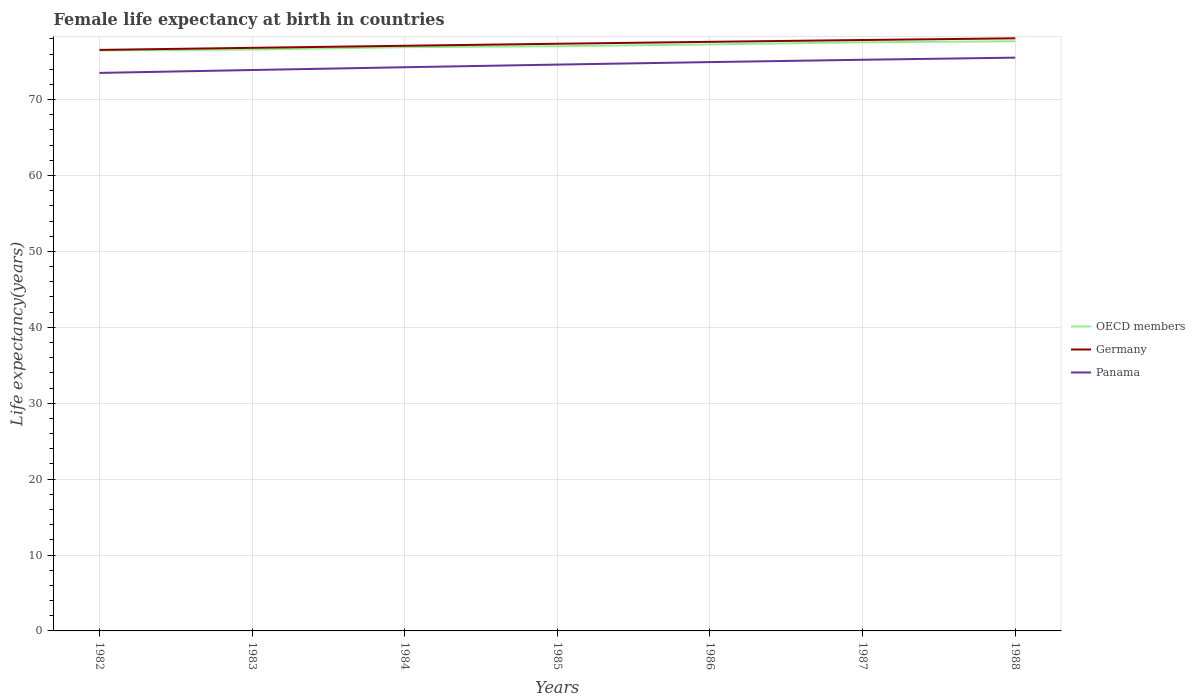How many different coloured lines are there?
Your answer should be very brief. 3. Is the number of lines equal to the number of legend labels?
Offer a very short reply. Yes. Across all years, what is the maximum female life expectancy at birth in Panama?
Make the answer very short. 73.52. In which year was the female life expectancy at birth in OECD members maximum?
Your answer should be very brief. 1982. What is the total female life expectancy at birth in Germany in the graph?
Your response must be concise. -0.54. What is the difference between the highest and the second highest female life expectancy at birth in Germany?
Offer a terse response. 1.53. What is the difference between the highest and the lowest female life expectancy at birth in OECD members?
Make the answer very short. 3. How many years are there in the graph?
Your answer should be compact. 7. Does the graph contain any zero values?
Your response must be concise. No. Does the graph contain grids?
Offer a very short reply. Yes. What is the title of the graph?
Offer a very short reply. Female life expectancy at birth in countries. Does "Bosnia and Herzegovina" appear as one of the legend labels in the graph?
Your answer should be very brief. No. What is the label or title of the X-axis?
Keep it short and to the point. Years. What is the label or title of the Y-axis?
Your answer should be very brief. Life expectancy(years). What is the Life expectancy(years) in OECD members in 1982?
Keep it short and to the point. 76.48. What is the Life expectancy(years) of Germany in 1982?
Make the answer very short. 76.55. What is the Life expectancy(years) of Panama in 1982?
Make the answer very short. 73.52. What is the Life expectancy(years) of OECD members in 1983?
Provide a short and direct response. 76.6. What is the Life expectancy(years) of Germany in 1983?
Offer a very short reply. 76.82. What is the Life expectancy(years) in Panama in 1983?
Offer a terse response. 73.9. What is the Life expectancy(years) in OECD members in 1984?
Your answer should be very brief. 76.9. What is the Life expectancy(years) of Germany in 1984?
Give a very brief answer. 77.1. What is the Life expectancy(years) of Panama in 1984?
Keep it short and to the point. 74.27. What is the Life expectancy(years) in OECD members in 1985?
Keep it short and to the point. 77.03. What is the Life expectancy(years) of Germany in 1985?
Offer a very short reply. 77.36. What is the Life expectancy(years) of Panama in 1985?
Your response must be concise. 74.61. What is the Life expectancy(years) of OECD members in 1986?
Give a very brief answer. 77.27. What is the Life expectancy(years) in Germany in 1986?
Give a very brief answer. 77.61. What is the Life expectancy(years) of Panama in 1986?
Make the answer very short. 74.94. What is the Life expectancy(years) in OECD members in 1987?
Keep it short and to the point. 77.56. What is the Life expectancy(years) of Germany in 1987?
Offer a very short reply. 77.85. What is the Life expectancy(years) of Panama in 1987?
Provide a short and direct response. 75.25. What is the Life expectancy(years) in OECD members in 1988?
Your response must be concise. 77.69. What is the Life expectancy(years) in Germany in 1988?
Your answer should be very brief. 78.08. What is the Life expectancy(years) of Panama in 1988?
Your answer should be compact. 75.53. Across all years, what is the maximum Life expectancy(years) in OECD members?
Provide a short and direct response. 77.69. Across all years, what is the maximum Life expectancy(years) of Germany?
Make the answer very short. 78.08. Across all years, what is the maximum Life expectancy(years) in Panama?
Ensure brevity in your answer.  75.53. Across all years, what is the minimum Life expectancy(years) in OECD members?
Your response must be concise. 76.48. Across all years, what is the minimum Life expectancy(years) of Germany?
Offer a terse response. 76.55. Across all years, what is the minimum Life expectancy(years) of Panama?
Make the answer very short. 73.52. What is the total Life expectancy(years) in OECD members in the graph?
Give a very brief answer. 539.53. What is the total Life expectancy(years) in Germany in the graph?
Provide a succinct answer. 541.37. What is the total Life expectancy(years) of Panama in the graph?
Keep it short and to the point. 522.03. What is the difference between the Life expectancy(years) in OECD members in 1982 and that in 1983?
Provide a short and direct response. -0.12. What is the difference between the Life expectancy(years) in Germany in 1982 and that in 1983?
Offer a very short reply. -0.27. What is the difference between the Life expectancy(years) of Panama in 1982 and that in 1983?
Provide a succinct answer. -0.38. What is the difference between the Life expectancy(years) in OECD members in 1982 and that in 1984?
Provide a short and direct response. -0.43. What is the difference between the Life expectancy(years) of Germany in 1982 and that in 1984?
Give a very brief answer. -0.55. What is the difference between the Life expectancy(years) of Panama in 1982 and that in 1984?
Your answer should be very brief. -0.75. What is the difference between the Life expectancy(years) in OECD members in 1982 and that in 1985?
Provide a succinct answer. -0.56. What is the difference between the Life expectancy(years) of Germany in 1982 and that in 1985?
Your response must be concise. -0.81. What is the difference between the Life expectancy(years) in Panama in 1982 and that in 1985?
Provide a short and direct response. -1.09. What is the difference between the Life expectancy(years) in OECD members in 1982 and that in 1986?
Your answer should be very brief. -0.79. What is the difference between the Life expectancy(years) of Germany in 1982 and that in 1986?
Your answer should be compact. -1.06. What is the difference between the Life expectancy(years) of Panama in 1982 and that in 1986?
Ensure brevity in your answer.  -1.42. What is the difference between the Life expectancy(years) of OECD members in 1982 and that in 1987?
Make the answer very short. -1.08. What is the difference between the Life expectancy(years) of Germany in 1982 and that in 1987?
Offer a very short reply. -1.3. What is the difference between the Life expectancy(years) of Panama in 1982 and that in 1987?
Your answer should be very brief. -1.73. What is the difference between the Life expectancy(years) in OECD members in 1982 and that in 1988?
Make the answer very short. -1.21. What is the difference between the Life expectancy(years) in Germany in 1982 and that in 1988?
Your response must be concise. -1.53. What is the difference between the Life expectancy(years) of Panama in 1982 and that in 1988?
Your answer should be compact. -2.01. What is the difference between the Life expectancy(years) in OECD members in 1983 and that in 1984?
Your answer should be very brief. -0.31. What is the difference between the Life expectancy(years) in Germany in 1983 and that in 1984?
Provide a short and direct response. -0.27. What is the difference between the Life expectancy(years) in Panama in 1983 and that in 1984?
Ensure brevity in your answer.  -0.36. What is the difference between the Life expectancy(years) of OECD members in 1983 and that in 1985?
Offer a very short reply. -0.44. What is the difference between the Life expectancy(years) of Germany in 1983 and that in 1985?
Provide a succinct answer. -0.54. What is the difference between the Life expectancy(years) in Panama in 1983 and that in 1985?
Offer a terse response. -0.71. What is the difference between the Life expectancy(years) in OECD members in 1983 and that in 1986?
Provide a succinct answer. -0.67. What is the difference between the Life expectancy(years) of Germany in 1983 and that in 1986?
Your answer should be compact. -0.79. What is the difference between the Life expectancy(years) of Panama in 1983 and that in 1986?
Provide a short and direct response. -1.04. What is the difference between the Life expectancy(years) of OECD members in 1983 and that in 1987?
Make the answer very short. -0.96. What is the difference between the Life expectancy(years) of Germany in 1983 and that in 1987?
Offer a terse response. -1.03. What is the difference between the Life expectancy(years) in Panama in 1983 and that in 1987?
Make the answer very short. -1.35. What is the difference between the Life expectancy(years) in OECD members in 1983 and that in 1988?
Your answer should be very brief. -1.09. What is the difference between the Life expectancy(years) in Germany in 1983 and that in 1988?
Provide a short and direct response. -1.25. What is the difference between the Life expectancy(years) of Panama in 1983 and that in 1988?
Provide a short and direct response. -1.63. What is the difference between the Life expectancy(years) of OECD members in 1984 and that in 1985?
Provide a short and direct response. -0.13. What is the difference between the Life expectancy(years) in Germany in 1984 and that in 1985?
Offer a very short reply. -0.26. What is the difference between the Life expectancy(years) in Panama in 1984 and that in 1985?
Offer a terse response. -0.35. What is the difference between the Life expectancy(years) of OECD members in 1984 and that in 1986?
Provide a short and direct response. -0.37. What is the difference between the Life expectancy(years) in Germany in 1984 and that in 1986?
Give a very brief answer. -0.52. What is the difference between the Life expectancy(years) of Panama in 1984 and that in 1986?
Your answer should be very brief. -0.68. What is the difference between the Life expectancy(years) in OECD members in 1984 and that in 1987?
Make the answer very short. -0.65. What is the difference between the Life expectancy(years) in Germany in 1984 and that in 1987?
Keep it short and to the point. -0.76. What is the difference between the Life expectancy(years) in Panama in 1984 and that in 1987?
Keep it short and to the point. -0.98. What is the difference between the Life expectancy(years) in OECD members in 1984 and that in 1988?
Offer a terse response. -0.78. What is the difference between the Life expectancy(years) in Germany in 1984 and that in 1988?
Your answer should be very brief. -0.98. What is the difference between the Life expectancy(years) in Panama in 1984 and that in 1988?
Provide a short and direct response. -1.26. What is the difference between the Life expectancy(years) in OECD members in 1985 and that in 1986?
Your response must be concise. -0.24. What is the difference between the Life expectancy(years) of Germany in 1985 and that in 1986?
Give a very brief answer. -0.25. What is the difference between the Life expectancy(years) in Panama in 1985 and that in 1986?
Offer a terse response. -0.33. What is the difference between the Life expectancy(years) of OECD members in 1985 and that in 1987?
Offer a terse response. -0.52. What is the difference between the Life expectancy(years) in Germany in 1985 and that in 1987?
Provide a short and direct response. -0.49. What is the difference between the Life expectancy(years) of Panama in 1985 and that in 1987?
Provide a short and direct response. -0.64. What is the difference between the Life expectancy(years) in OECD members in 1985 and that in 1988?
Keep it short and to the point. -0.65. What is the difference between the Life expectancy(years) of Germany in 1985 and that in 1988?
Your answer should be very brief. -0.72. What is the difference between the Life expectancy(years) of Panama in 1985 and that in 1988?
Offer a very short reply. -0.92. What is the difference between the Life expectancy(years) of OECD members in 1986 and that in 1987?
Offer a terse response. -0.29. What is the difference between the Life expectancy(years) of Germany in 1986 and that in 1987?
Provide a short and direct response. -0.24. What is the difference between the Life expectancy(years) of Panama in 1986 and that in 1987?
Your answer should be very brief. -0.31. What is the difference between the Life expectancy(years) in OECD members in 1986 and that in 1988?
Offer a very short reply. -0.42. What is the difference between the Life expectancy(years) in Germany in 1986 and that in 1988?
Give a very brief answer. -0.47. What is the difference between the Life expectancy(years) of Panama in 1986 and that in 1988?
Your response must be concise. -0.59. What is the difference between the Life expectancy(years) in OECD members in 1987 and that in 1988?
Give a very brief answer. -0.13. What is the difference between the Life expectancy(years) of Germany in 1987 and that in 1988?
Offer a terse response. -0.23. What is the difference between the Life expectancy(years) in Panama in 1987 and that in 1988?
Give a very brief answer. -0.28. What is the difference between the Life expectancy(years) of OECD members in 1982 and the Life expectancy(years) of Germany in 1983?
Make the answer very short. -0.35. What is the difference between the Life expectancy(years) of OECD members in 1982 and the Life expectancy(years) of Panama in 1983?
Your answer should be very brief. 2.58. What is the difference between the Life expectancy(years) in Germany in 1982 and the Life expectancy(years) in Panama in 1983?
Make the answer very short. 2.65. What is the difference between the Life expectancy(years) in OECD members in 1982 and the Life expectancy(years) in Germany in 1984?
Provide a short and direct response. -0.62. What is the difference between the Life expectancy(years) of OECD members in 1982 and the Life expectancy(years) of Panama in 1984?
Provide a succinct answer. 2.21. What is the difference between the Life expectancy(years) of Germany in 1982 and the Life expectancy(years) of Panama in 1984?
Keep it short and to the point. 2.28. What is the difference between the Life expectancy(years) in OECD members in 1982 and the Life expectancy(years) in Germany in 1985?
Your answer should be very brief. -0.88. What is the difference between the Life expectancy(years) of OECD members in 1982 and the Life expectancy(years) of Panama in 1985?
Ensure brevity in your answer.  1.86. What is the difference between the Life expectancy(years) in Germany in 1982 and the Life expectancy(years) in Panama in 1985?
Keep it short and to the point. 1.94. What is the difference between the Life expectancy(years) in OECD members in 1982 and the Life expectancy(years) in Germany in 1986?
Ensure brevity in your answer.  -1.14. What is the difference between the Life expectancy(years) in OECD members in 1982 and the Life expectancy(years) in Panama in 1986?
Your response must be concise. 1.53. What is the difference between the Life expectancy(years) in Germany in 1982 and the Life expectancy(years) in Panama in 1986?
Provide a short and direct response. 1.61. What is the difference between the Life expectancy(years) in OECD members in 1982 and the Life expectancy(years) in Germany in 1987?
Your answer should be very brief. -1.37. What is the difference between the Life expectancy(years) in OECD members in 1982 and the Life expectancy(years) in Panama in 1987?
Your answer should be very brief. 1.23. What is the difference between the Life expectancy(years) of Germany in 1982 and the Life expectancy(years) of Panama in 1987?
Ensure brevity in your answer.  1.3. What is the difference between the Life expectancy(years) in OECD members in 1982 and the Life expectancy(years) in Germany in 1988?
Ensure brevity in your answer.  -1.6. What is the difference between the Life expectancy(years) of OECD members in 1982 and the Life expectancy(years) of Panama in 1988?
Keep it short and to the point. 0.95. What is the difference between the Life expectancy(years) in Germany in 1982 and the Life expectancy(years) in Panama in 1988?
Provide a short and direct response. 1.02. What is the difference between the Life expectancy(years) in OECD members in 1983 and the Life expectancy(years) in Germany in 1984?
Make the answer very short. -0.5. What is the difference between the Life expectancy(years) of OECD members in 1983 and the Life expectancy(years) of Panama in 1984?
Offer a terse response. 2.33. What is the difference between the Life expectancy(years) in Germany in 1983 and the Life expectancy(years) in Panama in 1984?
Give a very brief answer. 2.56. What is the difference between the Life expectancy(years) in OECD members in 1983 and the Life expectancy(years) in Germany in 1985?
Keep it short and to the point. -0.76. What is the difference between the Life expectancy(years) of OECD members in 1983 and the Life expectancy(years) of Panama in 1985?
Give a very brief answer. 1.98. What is the difference between the Life expectancy(years) in Germany in 1983 and the Life expectancy(years) in Panama in 1985?
Provide a succinct answer. 2.21. What is the difference between the Life expectancy(years) in OECD members in 1983 and the Life expectancy(years) in Germany in 1986?
Offer a terse response. -1.02. What is the difference between the Life expectancy(years) of OECD members in 1983 and the Life expectancy(years) of Panama in 1986?
Your answer should be compact. 1.65. What is the difference between the Life expectancy(years) of Germany in 1983 and the Life expectancy(years) of Panama in 1986?
Offer a very short reply. 1.88. What is the difference between the Life expectancy(years) in OECD members in 1983 and the Life expectancy(years) in Germany in 1987?
Your answer should be very brief. -1.25. What is the difference between the Life expectancy(years) in OECD members in 1983 and the Life expectancy(years) in Panama in 1987?
Provide a succinct answer. 1.35. What is the difference between the Life expectancy(years) in Germany in 1983 and the Life expectancy(years) in Panama in 1987?
Give a very brief answer. 1.57. What is the difference between the Life expectancy(years) of OECD members in 1983 and the Life expectancy(years) of Germany in 1988?
Make the answer very short. -1.48. What is the difference between the Life expectancy(years) of OECD members in 1983 and the Life expectancy(years) of Panama in 1988?
Keep it short and to the point. 1.07. What is the difference between the Life expectancy(years) of Germany in 1983 and the Life expectancy(years) of Panama in 1988?
Give a very brief answer. 1.29. What is the difference between the Life expectancy(years) in OECD members in 1984 and the Life expectancy(years) in Germany in 1985?
Keep it short and to the point. -0.46. What is the difference between the Life expectancy(years) of OECD members in 1984 and the Life expectancy(years) of Panama in 1985?
Offer a terse response. 2.29. What is the difference between the Life expectancy(years) in Germany in 1984 and the Life expectancy(years) in Panama in 1985?
Provide a succinct answer. 2.48. What is the difference between the Life expectancy(years) in OECD members in 1984 and the Life expectancy(years) in Germany in 1986?
Keep it short and to the point. -0.71. What is the difference between the Life expectancy(years) in OECD members in 1984 and the Life expectancy(years) in Panama in 1986?
Your answer should be compact. 1.96. What is the difference between the Life expectancy(years) in Germany in 1984 and the Life expectancy(years) in Panama in 1986?
Your answer should be very brief. 2.15. What is the difference between the Life expectancy(years) of OECD members in 1984 and the Life expectancy(years) of Germany in 1987?
Offer a very short reply. -0.95. What is the difference between the Life expectancy(years) in OECD members in 1984 and the Life expectancy(years) in Panama in 1987?
Give a very brief answer. 1.65. What is the difference between the Life expectancy(years) of Germany in 1984 and the Life expectancy(years) of Panama in 1987?
Ensure brevity in your answer.  1.85. What is the difference between the Life expectancy(years) in OECD members in 1984 and the Life expectancy(years) in Germany in 1988?
Give a very brief answer. -1.17. What is the difference between the Life expectancy(years) of OECD members in 1984 and the Life expectancy(years) of Panama in 1988?
Offer a very short reply. 1.37. What is the difference between the Life expectancy(years) of Germany in 1984 and the Life expectancy(years) of Panama in 1988?
Keep it short and to the point. 1.56. What is the difference between the Life expectancy(years) in OECD members in 1985 and the Life expectancy(years) in Germany in 1986?
Provide a succinct answer. -0.58. What is the difference between the Life expectancy(years) of OECD members in 1985 and the Life expectancy(years) of Panama in 1986?
Offer a very short reply. 2.09. What is the difference between the Life expectancy(years) of Germany in 1985 and the Life expectancy(years) of Panama in 1986?
Your answer should be compact. 2.42. What is the difference between the Life expectancy(years) of OECD members in 1985 and the Life expectancy(years) of Germany in 1987?
Your answer should be compact. -0.82. What is the difference between the Life expectancy(years) of OECD members in 1985 and the Life expectancy(years) of Panama in 1987?
Ensure brevity in your answer.  1.78. What is the difference between the Life expectancy(years) of Germany in 1985 and the Life expectancy(years) of Panama in 1987?
Offer a terse response. 2.11. What is the difference between the Life expectancy(years) in OECD members in 1985 and the Life expectancy(years) in Germany in 1988?
Provide a succinct answer. -1.04. What is the difference between the Life expectancy(years) in OECD members in 1985 and the Life expectancy(years) in Panama in 1988?
Offer a very short reply. 1.5. What is the difference between the Life expectancy(years) in Germany in 1985 and the Life expectancy(years) in Panama in 1988?
Your answer should be very brief. 1.83. What is the difference between the Life expectancy(years) of OECD members in 1986 and the Life expectancy(years) of Germany in 1987?
Your answer should be compact. -0.58. What is the difference between the Life expectancy(years) of OECD members in 1986 and the Life expectancy(years) of Panama in 1987?
Your answer should be compact. 2.02. What is the difference between the Life expectancy(years) of Germany in 1986 and the Life expectancy(years) of Panama in 1987?
Offer a very short reply. 2.36. What is the difference between the Life expectancy(years) of OECD members in 1986 and the Life expectancy(years) of Germany in 1988?
Offer a very short reply. -0.81. What is the difference between the Life expectancy(years) in OECD members in 1986 and the Life expectancy(years) in Panama in 1988?
Make the answer very short. 1.74. What is the difference between the Life expectancy(years) of Germany in 1986 and the Life expectancy(years) of Panama in 1988?
Ensure brevity in your answer.  2.08. What is the difference between the Life expectancy(years) of OECD members in 1987 and the Life expectancy(years) of Germany in 1988?
Provide a succinct answer. -0.52. What is the difference between the Life expectancy(years) of OECD members in 1987 and the Life expectancy(years) of Panama in 1988?
Your answer should be very brief. 2.02. What is the difference between the Life expectancy(years) of Germany in 1987 and the Life expectancy(years) of Panama in 1988?
Your answer should be compact. 2.32. What is the average Life expectancy(years) in OECD members per year?
Keep it short and to the point. 77.08. What is the average Life expectancy(years) in Germany per year?
Offer a terse response. 77.34. What is the average Life expectancy(years) of Panama per year?
Keep it short and to the point. 74.58. In the year 1982, what is the difference between the Life expectancy(years) in OECD members and Life expectancy(years) in Germany?
Ensure brevity in your answer.  -0.07. In the year 1982, what is the difference between the Life expectancy(years) in OECD members and Life expectancy(years) in Panama?
Your response must be concise. 2.96. In the year 1982, what is the difference between the Life expectancy(years) in Germany and Life expectancy(years) in Panama?
Your answer should be very brief. 3.03. In the year 1983, what is the difference between the Life expectancy(years) in OECD members and Life expectancy(years) in Germany?
Keep it short and to the point. -0.23. In the year 1983, what is the difference between the Life expectancy(years) in OECD members and Life expectancy(years) in Panama?
Provide a succinct answer. 2.7. In the year 1983, what is the difference between the Life expectancy(years) of Germany and Life expectancy(years) of Panama?
Offer a terse response. 2.92. In the year 1984, what is the difference between the Life expectancy(years) in OECD members and Life expectancy(years) in Germany?
Keep it short and to the point. -0.19. In the year 1984, what is the difference between the Life expectancy(years) of OECD members and Life expectancy(years) of Panama?
Your answer should be compact. 2.64. In the year 1984, what is the difference between the Life expectancy(years) of Germany and Life expectancy(years) of Panama?
Your answer should be very brief. 2.83. In the year 1985, what is the difference between the Life expectancy(years) in OECD members and Life expectancy(years) in Germany?
Your response must be concise. -0.33. In the year 1985, what is the difference between the Life expectancy(years) in OECD members and Life expectancy(years) in Panama?
Make the answer very short. 2.42. In the year 1985, what is the difference between the Life expectancy(years) in Germany and Life expectancy(years) in Panama?
Make the answer very short. 2.75. In the year 1986, what is the difference between the Life expectancy(years) in OECD members and Life expectancy(years) in Germany?
Keep it short and to the point. -0.34. In the year 1986, what is the difference between the Life expectancy(years) of OECD members and Life expectancy(years) of Panama?
Ensure brevity in your answer.  2.33. In the year 1986, what is the difference between the Life expectancy(years) of Germany and Life expectancy(years) of Panama?
Keep it short and to the point. 2.67. In the year 1987, what is the difference between the Life expectancy(years) in OECD members and Life expectancy(years) in Germany?
Offer a very short reply. -0.3. In the year 1987, what is the difference between the Life expectancy(years) in OECD members and Life expectancy(years) in Panama?
Give a very brief answer. 2.31. In the year 1987, what is the difference between the Life expectancy(years) in Germany and Life expectancy(years) in Panama?
Your answer should be compact. 2.6. In the year 1988, what is the difference between the Life expectancy(years) of OECD members and Life expectancy(years) of Germany?
Provide a succinct answer. -0.39. In the year 1988, what is the difference between the Life expectancy(years) of OECD members and Life expectancy(years) of Panama?
Your answer should be compact. 2.16. In the year 1988, what is the difference between the Life expectancy(years) in Germany and Life expectancy(years) in Panama?
Your answer should be very brief. 2.55. What is the ratio of the Life expectancy(years) in Panama in 1982 to that in 1983?
Your answer should be very brief. 0.99. What is the ratio of the Life expectancy(years) of Germany in 1982 to that in 1984?
Ensure brevity in your answer.  0.99. What is the ratio of the Life expectancy(years) of Germany in 1982 to that in 1986?
Give a very brief answer. 0.99. What is the ratio of the Life expectancy(years) in OECD members in 1982 to that in 1987?
Provide a short and direct response. 0.99. What is the ratio of the Life expectancy(years) of Germany in 1982 to that in 1987?
Provide a short and direct response. 0.98. What is the ratio of the Life expectancy(years) in OECD members in 1982 to that in 1988?
Give a very brief answer. 0.98. What is the ratio of the Life expectancy(years) of Germany in 1982 to that in 1988?
Ensure brevity in your answer.  0.98. What is the ratio of the Life expectancy(years) in Panama in 1982 to that in 1988?
Your answer should be very brief. 0.97. What is the ratio of the Life expectancy(years) in Panama in 1983 to that in 1984?
Your answer should be compact. 1. What is the ratio of the Life expectancy(years) of Panama in 1983 to that in 1986?
Give a very brief answer. 0.99. What is the ratio of the Life expectancy(years) in OECD members in 1983 to that in 1987?
Keep it short and to the point. 0.99. What is the ratio of the Life expectancy(years) of Germany in 1983 to that in 1987?
Ensure brevity in your answer.  0.99. What is the ratio of the Life expectancy(years) of Panama in 1983 to that in 1987?
Ensure brevity in your answer.  0.98. What is the ratio of the Life expectancy(years) in OECD members in 1983 to that in 1988?
Your answer should be very brief. 0.99. What is the ratio of the Life expectancy(years) in Germany in 1983 to that in 1988?
Your answer should be very brief. 0.98. What is the ratio of the Life expectancy(years) in Panama in 1983 to that in 1988?
Make the answer very short. 0.98. What is the ratio of the Life expectancy(years) in OECD members in 1984 to that in 1985?
Keep it short and to the point. 1. What is the ratio of the Life expectancy(years) in OECD members in 1984 to that in 1987?
Make the answer very short. 0.99. What is the ratio of the Life expectancy(years) in Germany in 1984 to that in 1987?
Keep it short and to the point. 0.99. What is the ratio of the Life expectancy(years) in Panama in 1984 to that in 1987?
Keep it short and to the point. 0.99. What is the ratio of the Life expectancy(years) in Germany in 1984 to that in 1988?
Ensure brevity in your answer.  0.99. What is the ratio of the Life expectancy(years) of Panama in 1984 to that in 1988?
Offer a very short reply. 0.98. What is the ratio of the Life expectancy(years) of OECD members in 1985 to that in 1986?
Offer a very short reply. 1. What is the ratio of the Life expectancy(years) of OECD members in 1985 to that in 1988?
Give a very brief answer. 0.99. What is the ratio of the Life expectancy(years) in Panama in 1985 to that in 1988?
Your answer should be very brief. 0.99. What is the ratio of the Life expectancy(years) of Germany in 1986 to that in 1987?
Your answer should be very brief. 1. What is the ratio of the Life expectancy(years) of Germany in 1986 to that in 1988?
Your answer should be compact. 0.99. What is the ratio of the Life expectancy(years) in OECD members in 1987 to that in 1988?
Make the answer very short. 1. What is the ratio of the Life expectancy(years) of Germany in 1987 to that in 1988?
Ensure brevity in your answer.  1. What is the ratio of the Life expectancy(years) of Panama in 1987 to that in 1988?
Your answer should be very brief. 1. What is the difference between the highest and the second highest Life expectancy(years) of OECD members?
Your response must be concise. 0.13. What is the difference between the highest and the second highest Life expectancy(years) of Germany?
Provide a short and direct response. 0.23. What is the difference between the highest and the second highest Life expectancy(years) of Panama?
Your response must be concise. 0.28. What is the difference between the highest and the lowest Life expectancy(years) in OECD members?
Offer a terse response. 1.21. What is the difference between the highest and the lowest Life expectancy(years) in Germany?
Your answer should be compact. 1.53. What is the difference between the highest and the lowest Life expectancy(years) of Panama?
Offer a terse response. 2.01. 